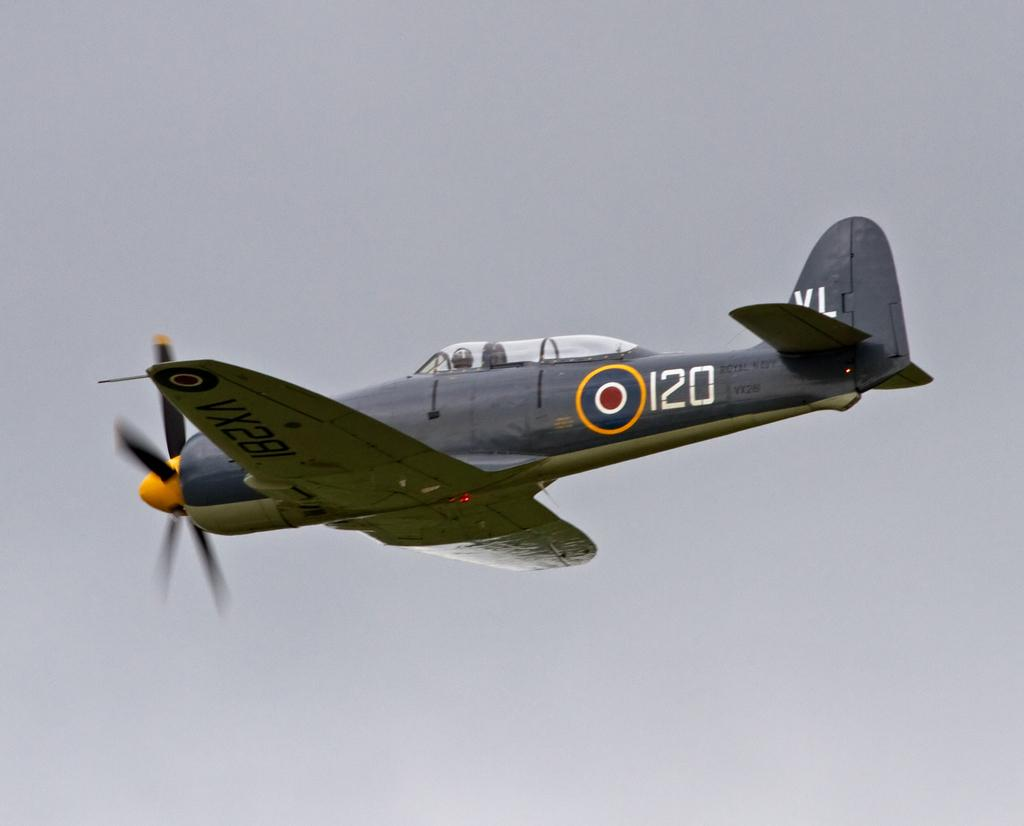<image>
Share a concise interpretation of the image provided. An airplane has the number 120 on the side of it. 